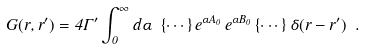<formula> <loc_0><loc_0><loc_500><loc_500>G ( { r } , { r } ^ { \prime } ) = 4 \Gamma ^ { \prime } \int _ { 0 } ^ { \infty } d \alpha \ \{ \cdots \} \, e ^ { \alpha A _ { 0 } } \, e ^ { \alpha B _ { 0 } } \, \{ \cdots \} \, \delta ( { r } - { r } ^ { \prime } ) \ .</formula> 